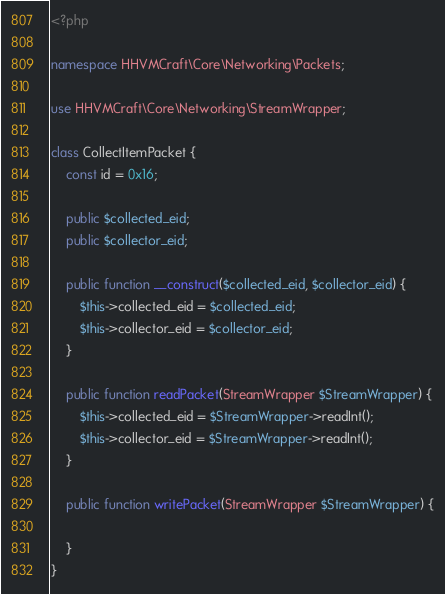Convert code to text. <code><loc_0><loc_0><loc_500><loc_500><_PHP_><?php

namespace HHVMCraft\Core\Networking\Packets;

use HHVMCraft\Core\Networking\StreamWrapper;

class CollectItemPacket {
	const id = 0x16;

	public $collected_eid;
	public $collector_eid;

	public function __construct($collected_eid, $collector_eid) {
		$this->collected_eid = $collected_eid;
		$this->collector_eid = $collector_eid;
	}

	public function readPacket(StreamWrapper $StreamWrapper) {
		$this->collected_eid = $StreamWrapper->readInt();
		$this->collector_eid = $StreamWrapper->readInt();
	}

	public function writePacket(StreamWrapper $StreamWrapper) {

	}
}
</code> 